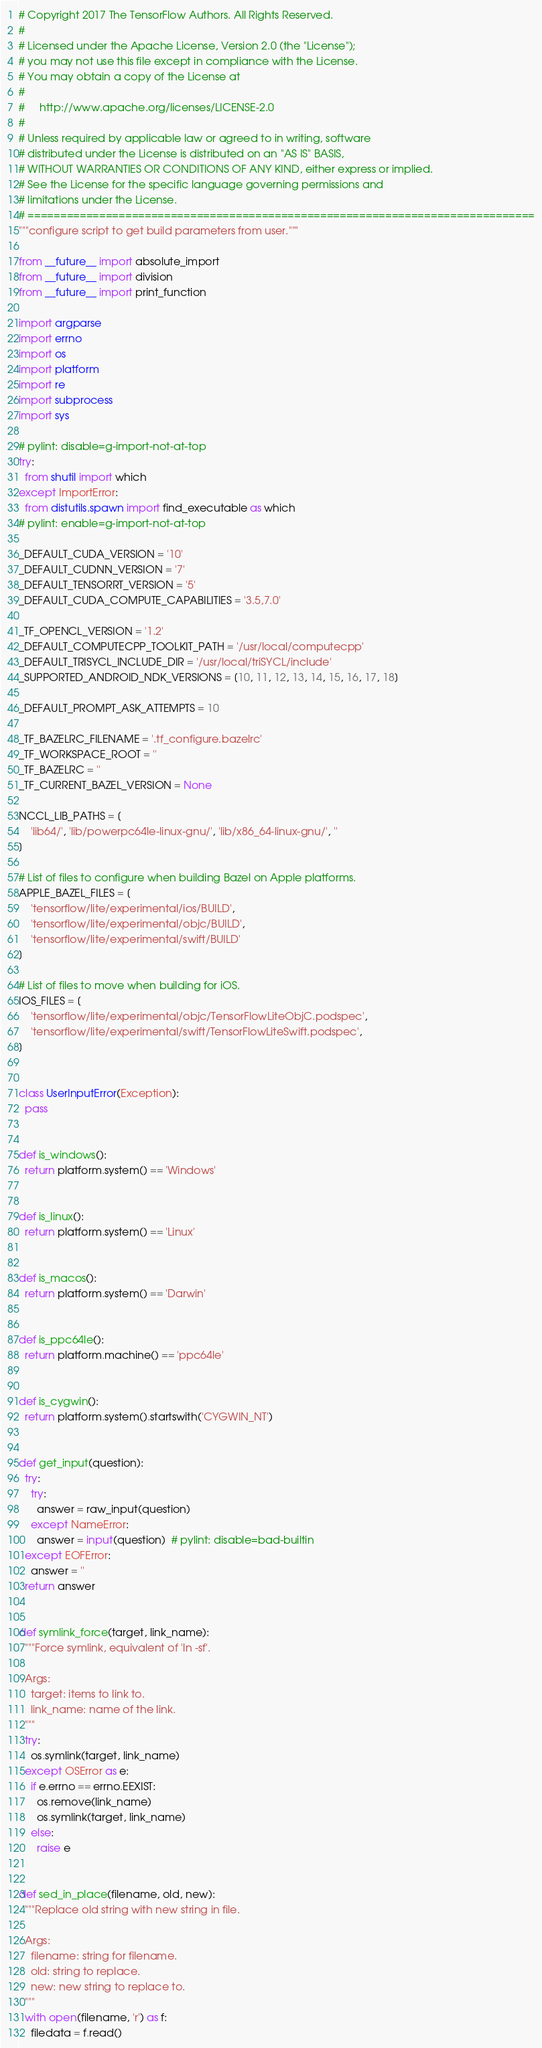Convert code to text. <code><loc_0><loc_0><loc_500><loc_500><_Python_># Copyright 2017 The TensorFlow Authors. All Rights Reserved.
#
# Licensed under the Apache License, Version 2.0 (the "License");
# you may not use this file except in compliance with the License.
# You may obtain a copy of the License at
#
#     http://www.apache.org/licenses/LICENSE-2.0
#
# Unless required by applicable law or agreed to in writing, software
# distributed under the License is distributed on an "AS IS" BASIS,
# WITHOUT WARRANTIES OR CONDITIONS OF ANY KIND, either express or implied.
# See the License for the specific language governing permissions and
# limitations under the License.
# ==============================================================================
"""configure script to get build parameters from user."""

from __future__ import absolute_import
from __future__ import division
from __future__ import print_function

import argparse
import errno
import os
import platform
import re
import subprocess
import sys

# pylint: disable=g-import-not-at-top
try:
  from shutil import which
except ImportError:
  from distutils.spawn import find_executable as which
# pylint: enable=g-import-not-at-top

_DEFAULT_CUDA_VERSION = '10'
_DEFAULT_CUDNN_VERSION = '7'
_DEFAULT_TENSORRT_VERSION = '5'
_DEFAULT_CUDA_COMPUTE_CAPABILITIES = '3.5,7.0'

_TF_OPENCL_VERSION = '1.2'
_DEFAULT_COMPUTECPP_TOOLKIT_PATH = '/usr/local/computecpp'
_DEFAULT_TRISYCL_INCLUDE_DIR = '/usr/local/triSYCL/include'
_SUPPORTED_ANDROID_NDK_VERSIONS = [10, 11, 12, 13, 14, 15, 16, 17, 18]

_DEFAULT_PROMPT_ASK_ATTEMPTS = 10

_TF_BAZELRC_FILENAME = '.tf_configure.bazelrc'
_TF_WORKSPACE_ROOT = ''
_TF_BAZELRC = ''
_TF_CURRENT_BAZEL_VERSION = None

NCCL_LIB_PATHS = [
    'lib64/', 'lib/powerpc64le-linux-gnu/', 'lib/x86_64-linux-gnu/', ''
]

# List of files to configure when building Bazel on Apple platforms.
APPLE_BAZEL_FILES = [
    'tensorflow/lite/experimental/ios/BUILD',
    'tensorflow/lite/experimental/objc/BUILD',
    'tensorflow/lite/experimental/swift/BUILD'
]

# List of files to move when building for iOS.
IOS_FILES = [
    'tensorflow/lite/experimental/objc/TensorFlowLiteObjC.podspec',
    'tensorflow/lite/experimental/swift/TensorFlowLiteSwift.podspec',
]


class UserInputError(Exception):
  pass


def is_windows():
  return platform.system() == 'Windows'


def is_linux():
  return platform.system() == 'Linux'


def is_macos():
  return platform.system() == 'Darwin'


def is_ppc64le():
  return platform.machine() == 'ppc64le'


def is_cygwin():
  return platform.system().startswith('CYGWIN_NT')


def get_input(question):
  try:
    try:
      answer = raw_input(question)
    except NameError:
      answer = input(question)  # pylint: disable=bad-builtin
  except EOFError:
    answer = ''
  return answer


def symlink_force(target, link_name):
  """Force symlink, equivalent of 'ln -sf'.

  Args:
    target: items to link to.
    link_name: name of the link.
  """
  try:
    os.symlink(target, link_name)
  except OSError as e:
    if e.errno == errno.EEXIST:
      os.remove(link_name)
      os.symlink(target, link_name)
    else:
      raise e


def sed_in_place(filename, old, new):
  """Replace old string with new string in file.

  Args:
    filename: string for filename.
    old: string to replace.
    new: new string to replace to.
  """
  with open(filename, 'r') as f:
    filedata = f.read()</code> 